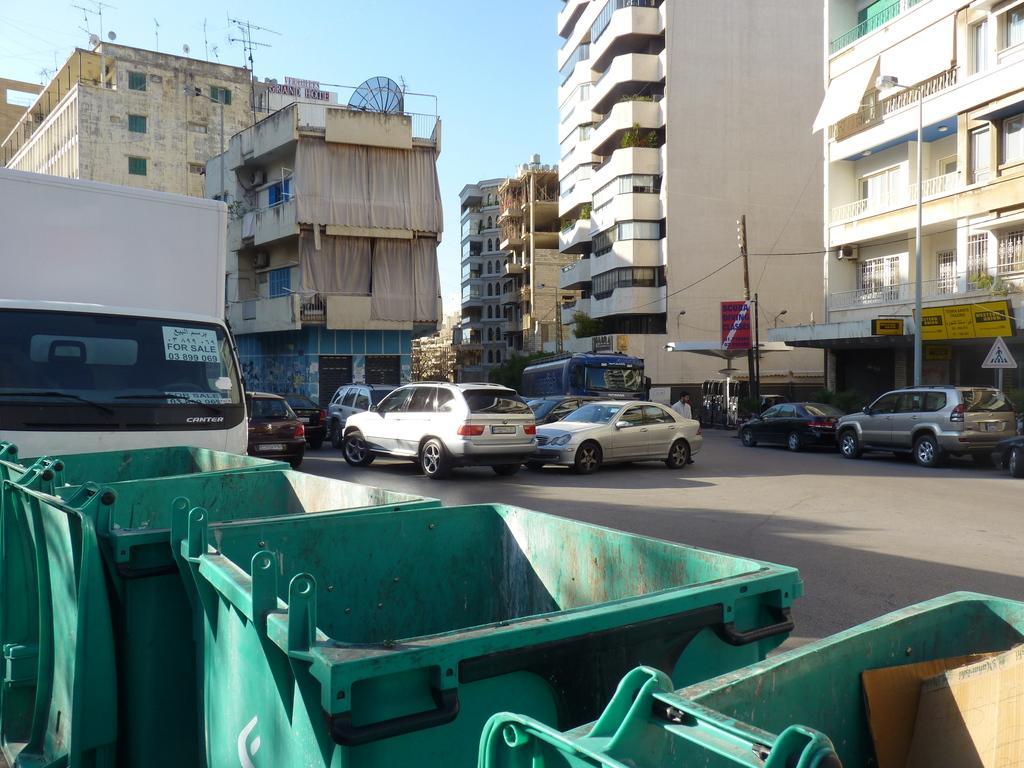Can you describe this image briefly? In this image in the center there are some vehicles, and in the background there are some buildings, poles, wires. And in the foreground there are dustbins, at the top of the image there is sky and in the center there is a road and also there are some other objects on the buildings. 